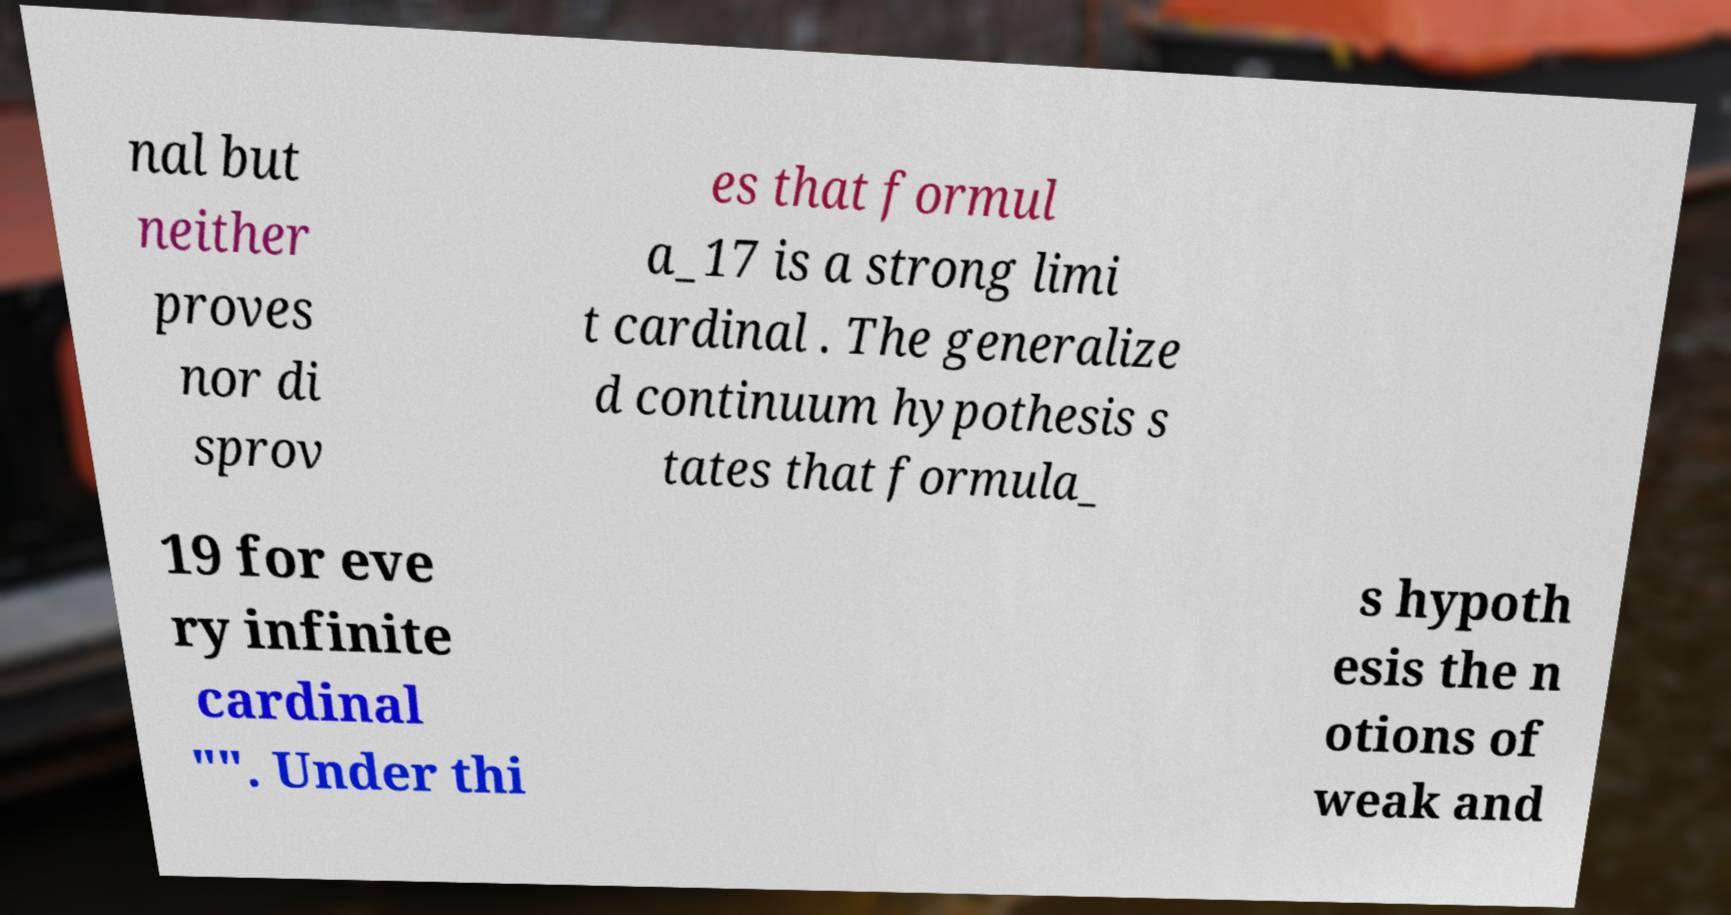I need the written content from this picture converted into text. Can you do that? nal but neither proves nor di sprov es that formul a_17 is a strong limi t cardinal . The generalize d continuum hypothesis s tates that formula_ 19 for eve ry infinite cardinal "". Under thi s hypoth esis the n otions of weak and 